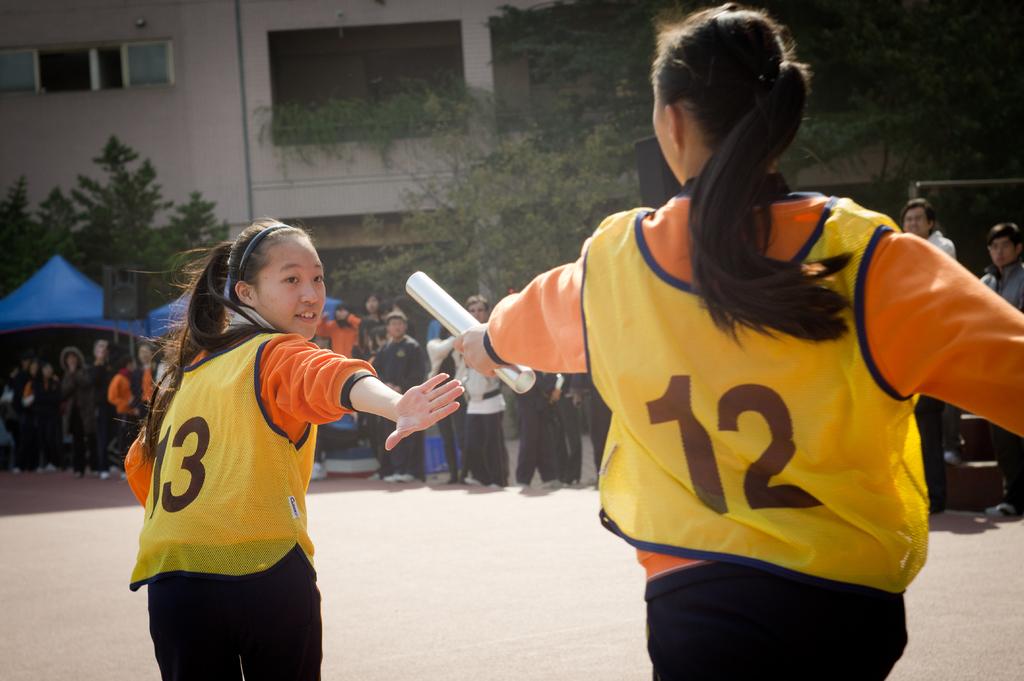Which athlete number is passing the baton?
Keep it short and to the point. 12. 